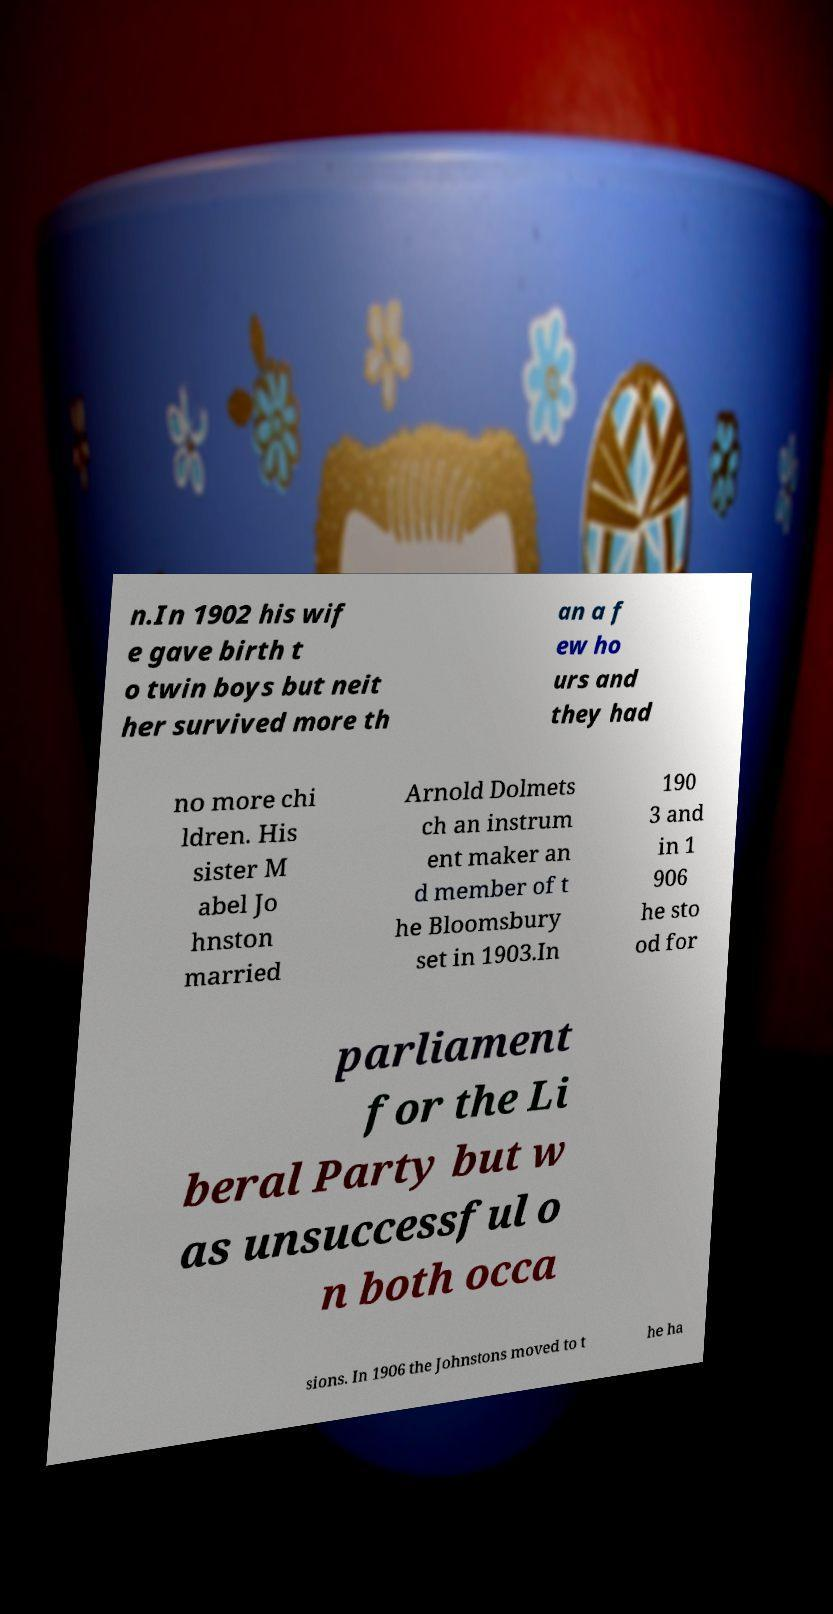Can you accurately transcribe the text from the provided image for me? n.In 1902 his wif e gave birth t o twin boys but neit her survived more th an a f ew ho urs and they had no more chi ldren. His sister M abel Jo hnston married Arnold Dolmets ch an instrum ent maker an d member of t he Bloomsbury set in 1903.In 190 3 and in 1 906 he sto od for parliament for the Li beral Party but w as unsuccessful o n both occa sions. In 1906 the Johnstons moved to t he ha 